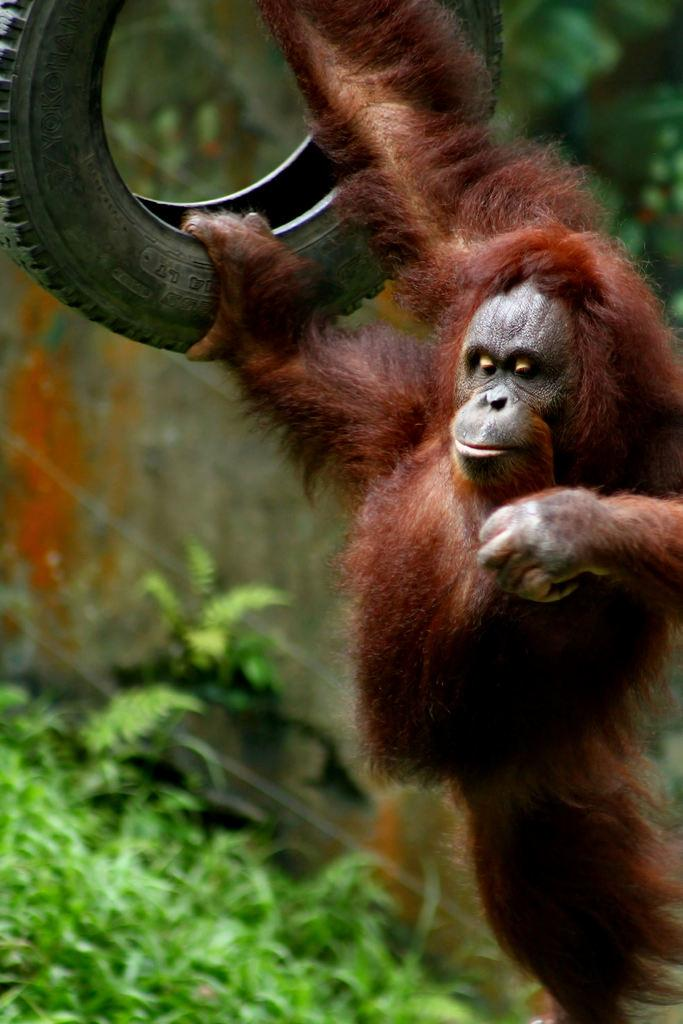What type of animal is in the image? There is an animal in the image, but the specific type cannot be determined from the provided facts. What is the animal doing in the image? The animal is holding a tire in the image. What can be seen in the background of the image? There are plants, trees, and a fence in the background of the image. When was the image likely taken? The image was likely taken during the day, as there is no mention of darkness or artificial lighting. What language is the goose speaking in the image? There is no goose present in the image, and therefore no such conversation can be observed. What type of flowers are growing in the image? There is no mention of flowers in the provided facts, so we cannot determine if any are present in the image. 